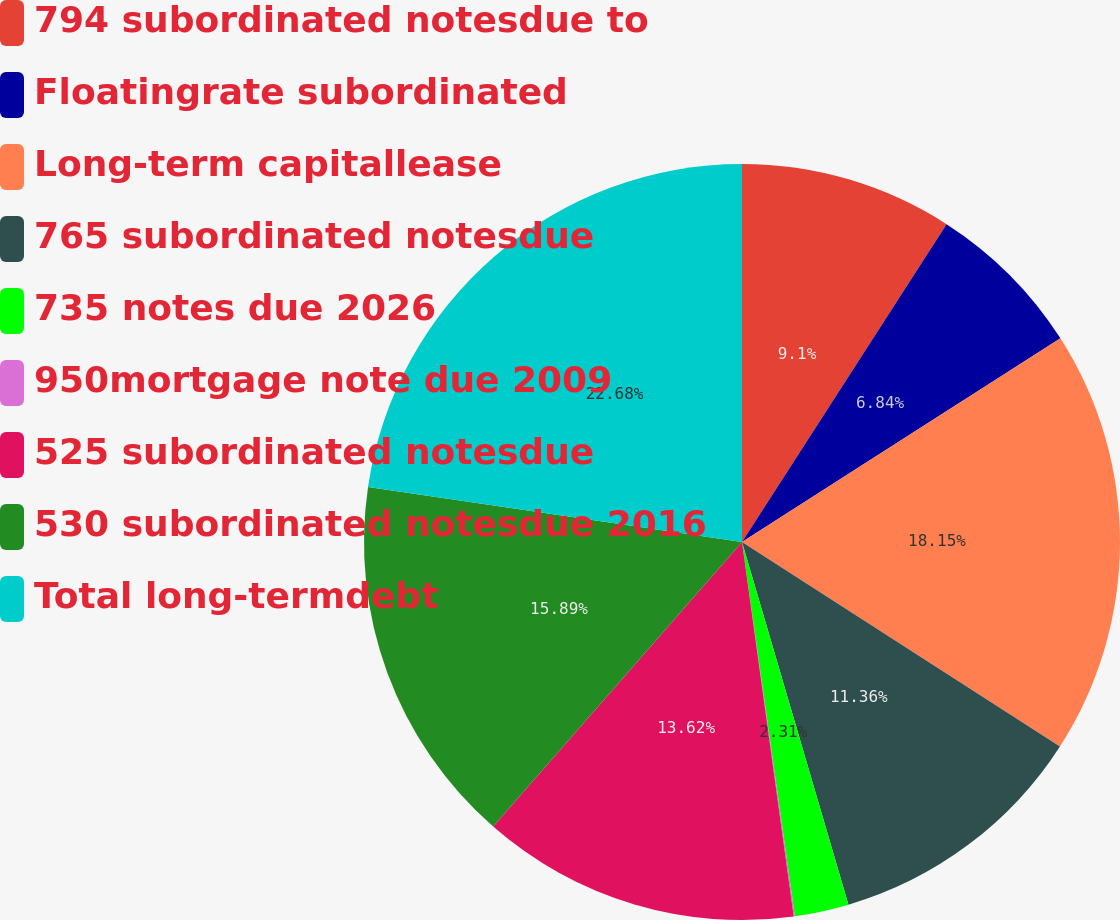Convert chart to OTSL. <chart><loc_0><loc_0><loc_500><loc_500><pie_chart><fcel>794 subordinated notesdue to<fcel>Floatingrate subordinated<fcel>Long-term capitallease<fcel>765 subordinated notesdue<fcel>735 notes due 2026<fcel>950mortgage note due 2009<fcel>525 subordinated notesdue<fcel>530 subordinated notesdue 2016<fcel>Total long-termdebt<nl><fcel>9.1%<fcel>6.84%<fcel>18.15%<fcel>11.36%<fcel>2.31%<fcel>0.05%<fcel>13.62%<fcel>15.89%<fcel>22.67%<nl></chart> 